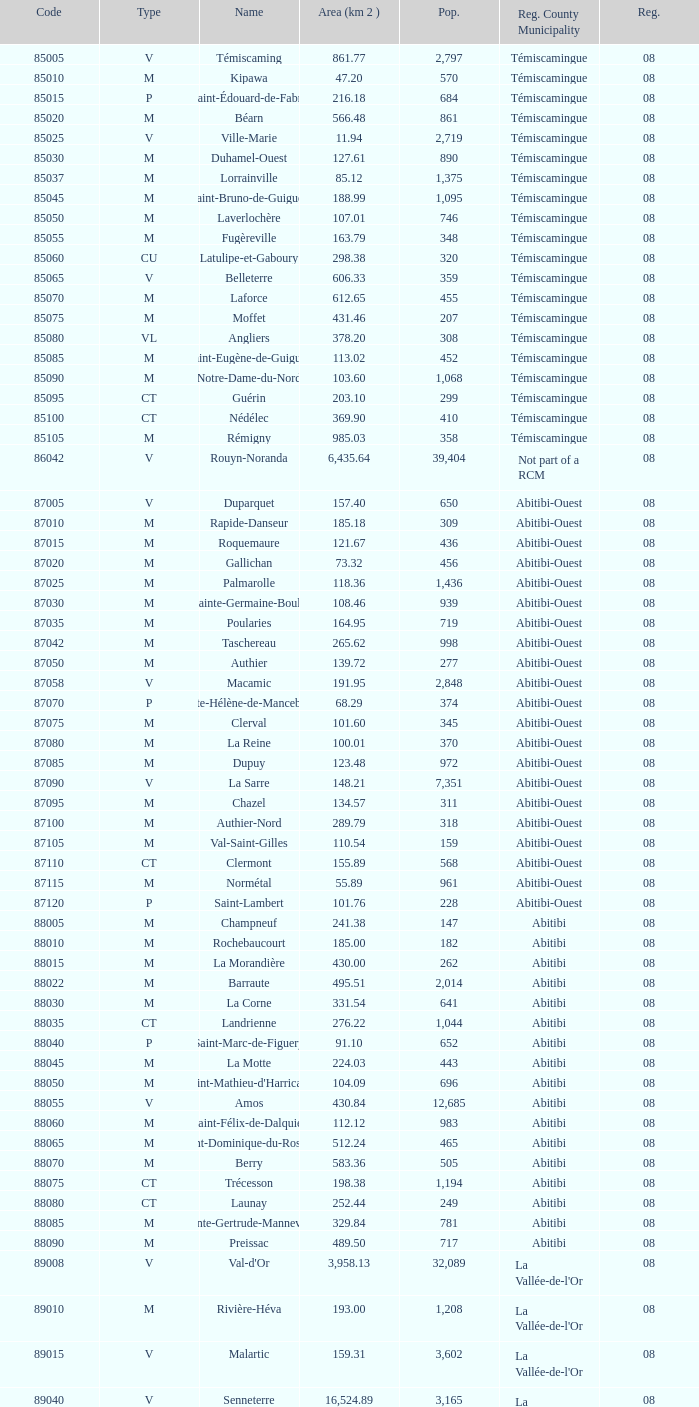Parse the table in full. {'header': ['Code', 'Type', 'Name', 'Area (km 2 )', 'Pop.', 'Reg. County Municipality', 'Reg.'], 'rows': [['85005', 'V', 'Témiscaming', '861.77', '2,797', 'Témiscamingue', '08'], ['85010', 'M', 'Kipawa', '47.20', '570', 'Témiscamingue', '08'], ['85015', 'P', 'Saint-Édouard-de-Fabre', '216.18', '684', 'Témiscamingue', '08'], ['85020', 'M', 'Béarn', '566.48', '861', 'Témiscamingue', '08'], ['85025', 'V', 'Ville-Marie', '11.94', '2,719', 'Témiscamingue', '08'], ['85030', 'M', 'Duhamel-Ouest', '127.61', '890', 'Témiscamingue', '08'], ['85037', 'M', 'Lorrainville', '85.12', '1,375', 'Témiscamingue', '08'], ['85045', 'M', 'Saint-Bruno-de-Guigues', '188.99', '1,095', 'Témiscamingue', '08'], ['85050', 'M', 'Laverlochère', '107.01', '746', 'Témiscamingue', '08'], ['85055', 'M', 'Fugèreville', '163.79', '348', 'Témiscamingue', '08'], ['85060', 'CU', 'Latulipe-et-Gaboury', '298.38', '320', 'Témiscamingue', '08'], ['85065', 'V', 'Belleterre', '606.33', '359', 'Témiscamingue', '08'], ['85070', 'M', 'Laforce', '612.65', '455', 'Témiscamingue', '08'], ['85075', 'M', 'Moffet', '431.46', '207', 'Témiscamingue', '08'], ['85080', 'VL', 'Angliers', '378.20', '308', 'Témiscamingue', '08'], ['85085', 'M', 'Saint-Eugène-de-Guigues', '113.02', '452', 'Témiscamingue', '08'], ['85090', 'M', 'Notre-Dame-du-Nord', '103.60', '1,068', 'Témiscamingue', '08'], ['85095', 'CT', 'Guérin', '203.10', '299', 'Témiscamingue', '08'], ['85100', 'CT', 'Nédélec', '369.90', '410', 'Témiscamingue', '08'], ['85105', 'M', 'Rémigny', '985.03', '358', 'Témiscamingue', '08'], ['86042', 'V', 'Rouyn-Noranda', '6,435.64', '39,404', 'Not part of a RCM', '08'], ['87005', 'V', 'Duparquet', '157.40', '650', 'Abitibi-Ouest', '08'], ['87010', 'M', 'Rapide-Danseur', '185.18', '309', 'Abitibi-Ouest', '08'], ['87015', 'M', 'Roquemaure', '121.67', '436', 'Abitibi-Ouest', '08'], ['87020', 'M', 'Gallichan', '73.32', '456', 'Abitibi-Ouest', '08'], ['87025', 'M', 'Palmarolle', '118.36', '1,436', 'Abitibi-Ouest', '08'], ['87030', 'M', 'Sainte-Germaine-Boulé', '108.46', '939', 'Abitibi-Ouest', '08'], ['87035', 'M', 'Poularies', '164.95', '719', 'Abitibi-Ouest', '08'], ['87042', 'M', 'Taschereau', '265.62', '998', 'Abitibi-Ouest', '08'], ['87050', 'M', 'Authier', '139.72', '277', 'Abitibi-Ouest', '08'], ['87058', 'V', 'Macamic', '191.95', '2,848', 'Abitibi-Ouest', '08'], ['87070', 'P', 'Sainte-Hélène-de-Mancebourg', '68.29', '374', 'Abitibi-Ouest', '08'], ['87075', 'M', 'Clerval', '101.60', '345', 'Abitibi-Ouest', '08'], ['87080', 'M', 'La Reine', '100.01', '370', 'Abitibi-Ouest', '08'], ['87085', 'M', 'Dupuy', '123.48', '972', 'Abitibi-Ouest', '08'], ['87090', 'V', 'La Sarre', '148.21', '7,351', 'Abitibi-Ouest', '08'], ['87095', 'M', 'Chazel', '134.57', '311', 'Abitibi-Ouest', '08'], ['87100', 'M', 'Authier-Nord', '289.79', '318', 'Abitibi-Ouest', '08'], ['87105', 'M', 'Val-Saint-Gilles', '110.54', '159', 'Abitibi-Ouest', '08'], ['87110', 'CT', 'Clermont', '155.89', '568', 'Abitibi-Ouest', '08'], ['87115', 'M', 'Normétal', '55.89', '961', 'Abitibi-Ouest', '08'], ['87120', 'P', 'Saint-Lambert', '101.76', '228', 'Abitibi-Ouest', '08'], ['88005', 'M', 'Champneuf', '241.38', '147', 'Abitibi', '08'], ['88010', 'M', 'Rochebaucourt', '185.00', '182', 'Abitibi', '08'], ['88015', 'M', 'La Morandière', '430.00', '262', 'Abitibi', '08'], ['88022', 'M', 'Barraute', '495.51', '2,014', 'Abitibi', '08'], ['88030', 'M', 'La Corne', '331.54', '641', 'Abitibi', '08'], ['88035', 'CT', 'Landrienne', '276.22', '1,044', 'Abitibi', '08'], ['88040', 'P', 'Saint-Marc-de-Figuery', '91.10', '652', 'Abitibi', '08'], ['88045', 'M', 'La Motte', '224.03', '443', 'Abitibi', '08'], ['88050', 'M', "Saint-Mathieu-d'Harricana", '104.09', '696', 'Abitibi', '08'], ['88055', 'V', 'Amos', '430.84', '12,685', 'Abitibi', '08'], ['88060', 'M', 'Saint-Félix-de-Dalquier', '112.12', '983', 'Abitibi', '08'], ['88065', 'M', 'Saint-Dominique-du-Rosaire', '512.24', '465', 'Abitibi', '08'], ['88070', 'M', 'Berry', '583.36', '505', 'Abitibi', '08'], ['88075', 'CT', 'Trécesson', '198.38', '1,194', 'Abitibi', '08'], ['88080', 'CT', 'Launay', '252.44', '249', 'Abitibi', '08'], ['88085', 'M', 'Sainte-Gertrude-Manneville', '329.84', '781', 'Abitibi', '08'], ['88090', 'M', 'Preissac', '489.50', '717', 'Abitibi', '08'], ['89008', 'V', "Val-d'Or", '3,958.13', '32,089', "La Vallée-de-l'Or", '08'], ['89010', 'M', 'Rivière-Héva', '193.00', '1,208', "La Vallée-de-l'Or", '08'], ['89015', 'V', 'Malartic', '159.31', '3,602', "La Vallée-de-l'Or", '08'], ['89040', 'V', 'Senneterre', '16,524.89', '3,165', "La Vallée-de-l'Or", '08'], ['89045', 'P', 'Senneterre', '432.98', '1,146', "La Vallée-de-l'Or", '08'], ['89050', 'M', 'Belcourt', '411.23', '261', "La Vallée-de-l'Or", '08']]} What type has a population of 370? M. 